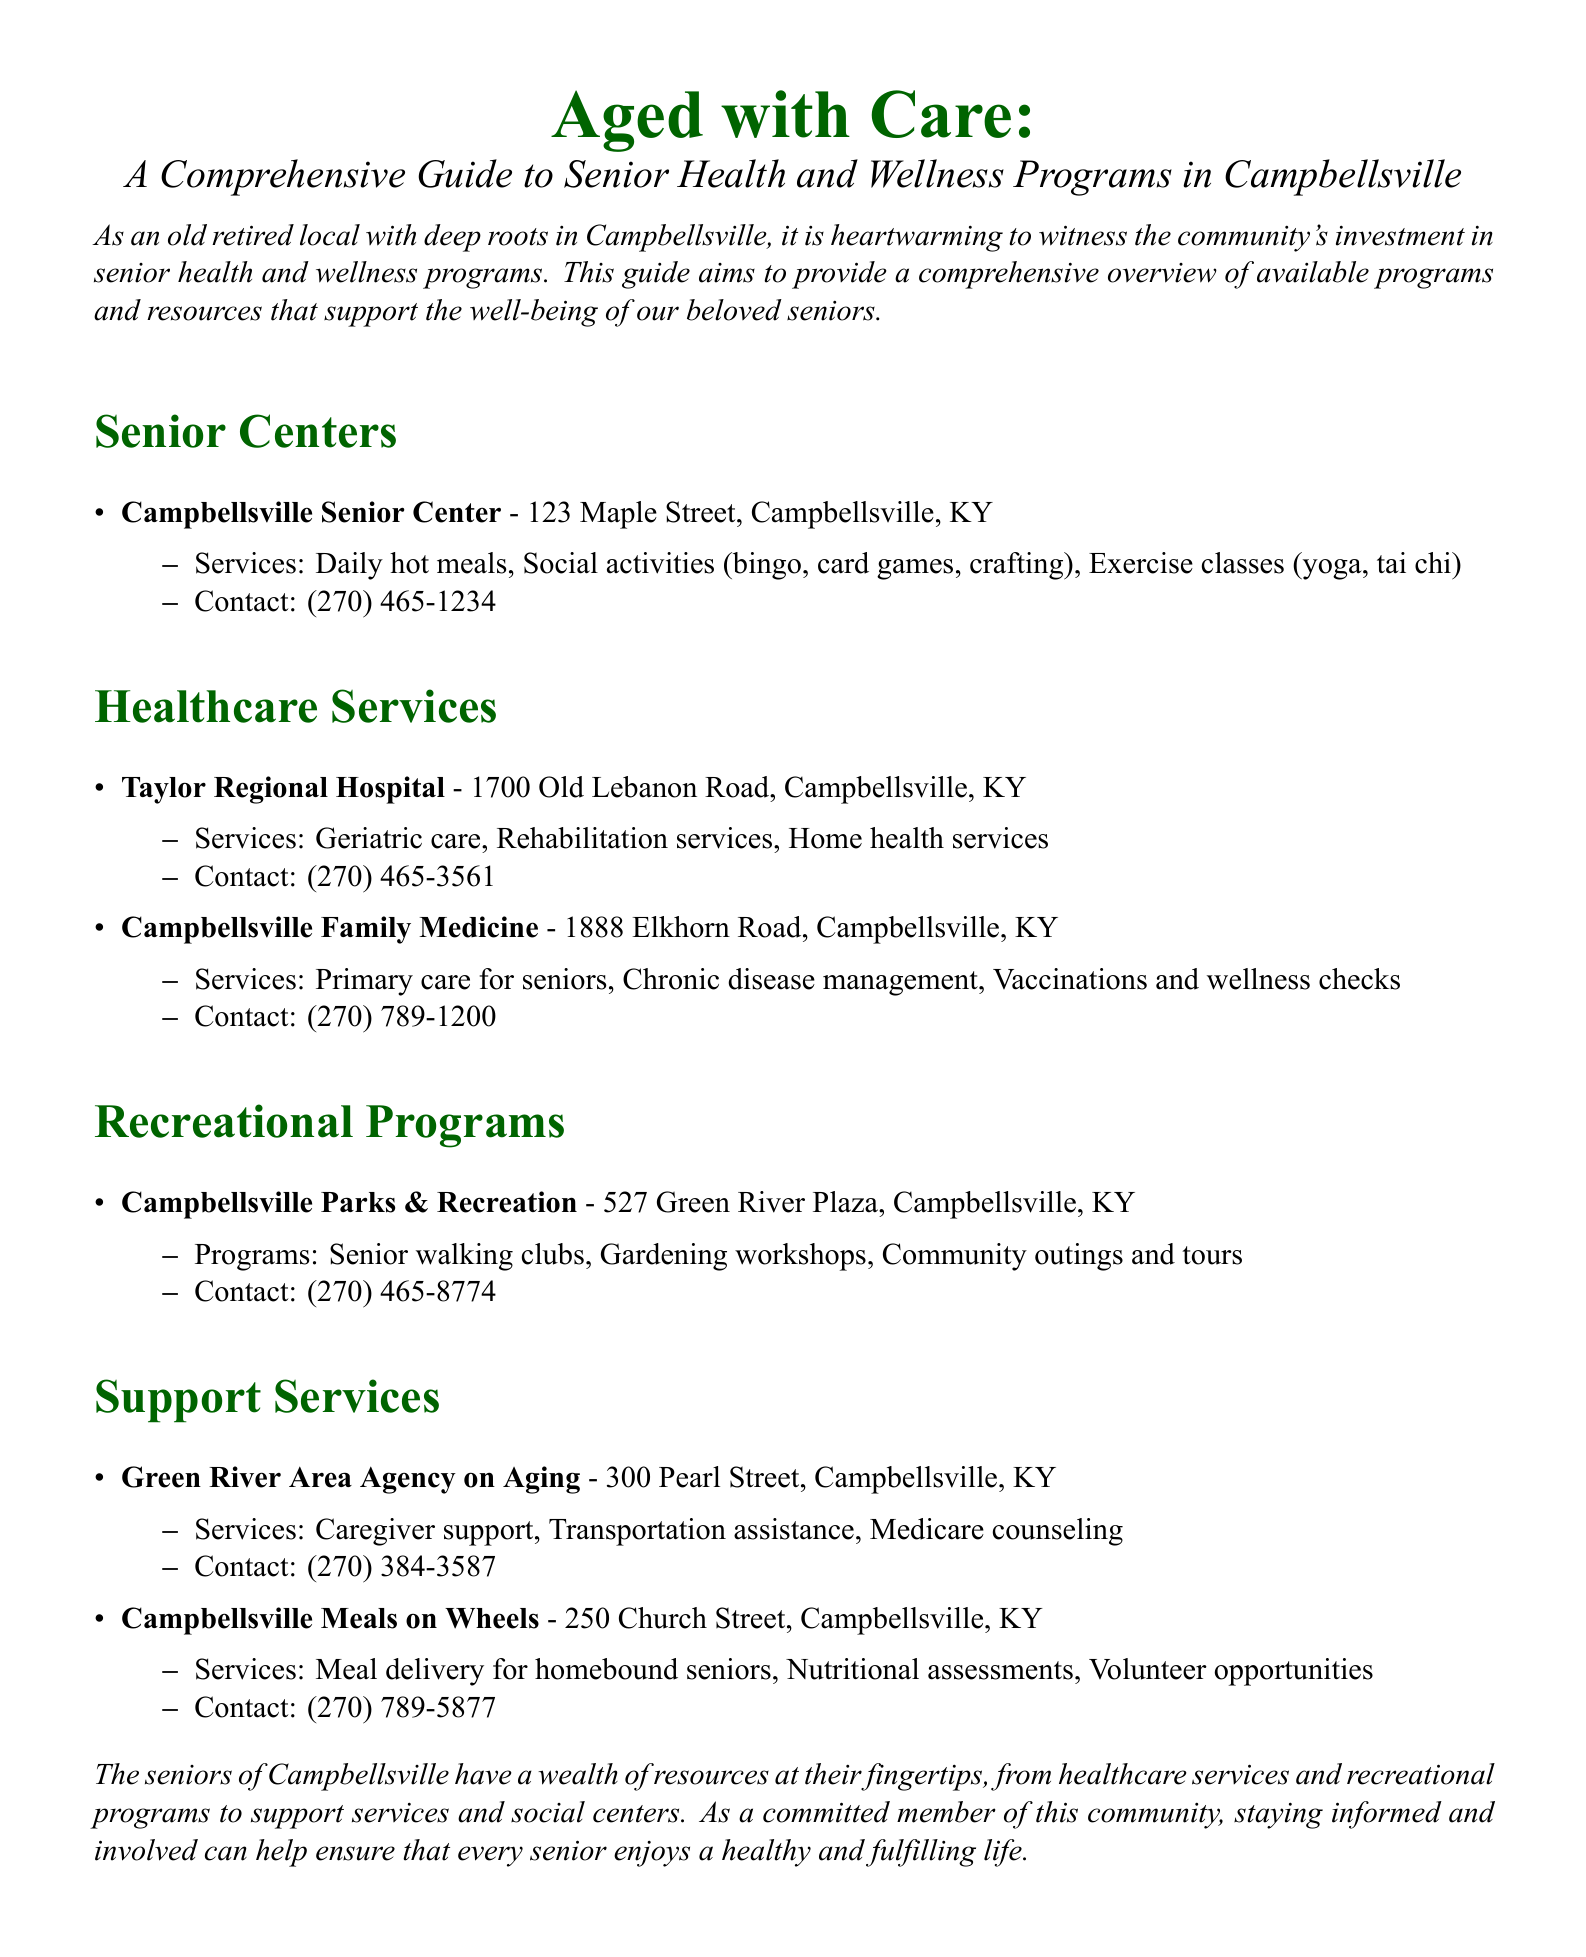What is the address of the Campbellsville Senior Center? The address of the Campbellsville Senior Center is provided in the document, which is crucial for locating it.
Answer: 123 Maple Street, Campbellsville, KY What services does Taylor Regional Hospital offer? The document lists specific services offered by Taylor Regional Hospital, which include specialized care for seniors.
Answer: Geriatric care, Rehabilitation services, Home health services What contact number is provided for Campbellsville Meals on Wheels? The document includes contact information for Campbellsville Meals on Wheels, which is important for those seeking their services.
Answer: (270) 789-5877 What type of programs does Campbellsville Parks & Recreation provide for seniors? The document specifies the recreational programs available for seniors, indicating community engagement opportunities.
Answer: Senior walking clubs, Gardening workshops, Community outings and tours What organization offers caregiver support services in Campbellsville? The document identifies local organizations that provide various support services, including caregiver support.
Answer: Green River Area Agency on Aging How many healthcare service providers are mentioned in the document? The document lists distinct healthcare service providers available to seniors in Campbellsville, which helps in identifying resources.
Answer: 2 